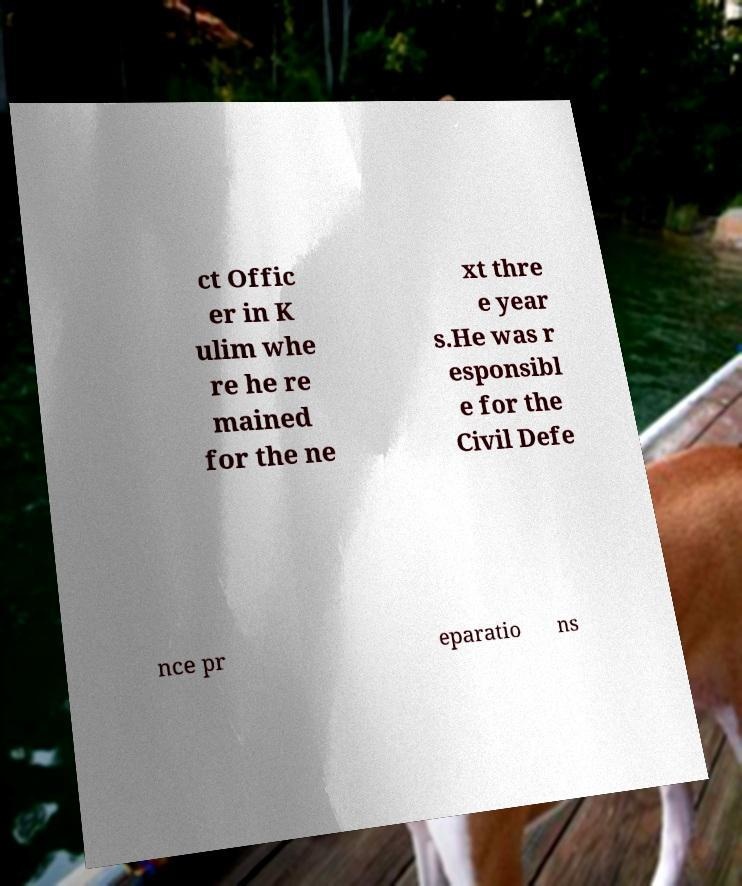There's text embedded in this image that I need extracted. Can you transcribe it verbatim? ct Offic er in K ulim whe re he re mained for the ne xt thre e year s.He was r esponsibl e for the Civil Defe nce pr eparatio ns 